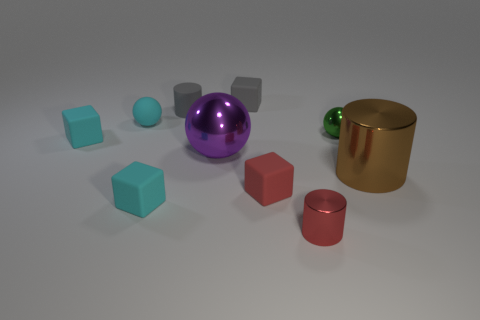What shape is the purple object that is the same size as the brown shiny object?
Your answer should be very brief. Sphere. What number of other objects are there of the same color as the rubber cylinder?
Give a very brief answer. 1. Does the large thing that is in front of the purple sphere have the same shape as the tiny shiny thing that is behind the small red cube?
Give a very brief answer. No. What number of objects are metal objects that are left of the tiny green shiny thing or blocks on the right side of the cyan matte ball?
Give a very brief answer. 5. What number of other things are made of the same material as the large purple object?
Your response must be concise. 3. Do the cyan object right of the small cyan sphere and the red cylinder have the same material?
Your response must be concise. No. Are there more large brown cylinders to the left of the tiny matte ball than tiny matte blocks behind the small green metal sphere?
Keep it short and to the point. No. How many things are rubber blocks that are on the right side of the matte ball or brown cylinders?
Provide a short and direct response. 4. There is a red object that is made of the same material as the cyan ball; what is its shape?
Provide a short and direct response. Cube. Is there anything else that has the same shape as the purple thing?
Offer a very short reply. Yes. 